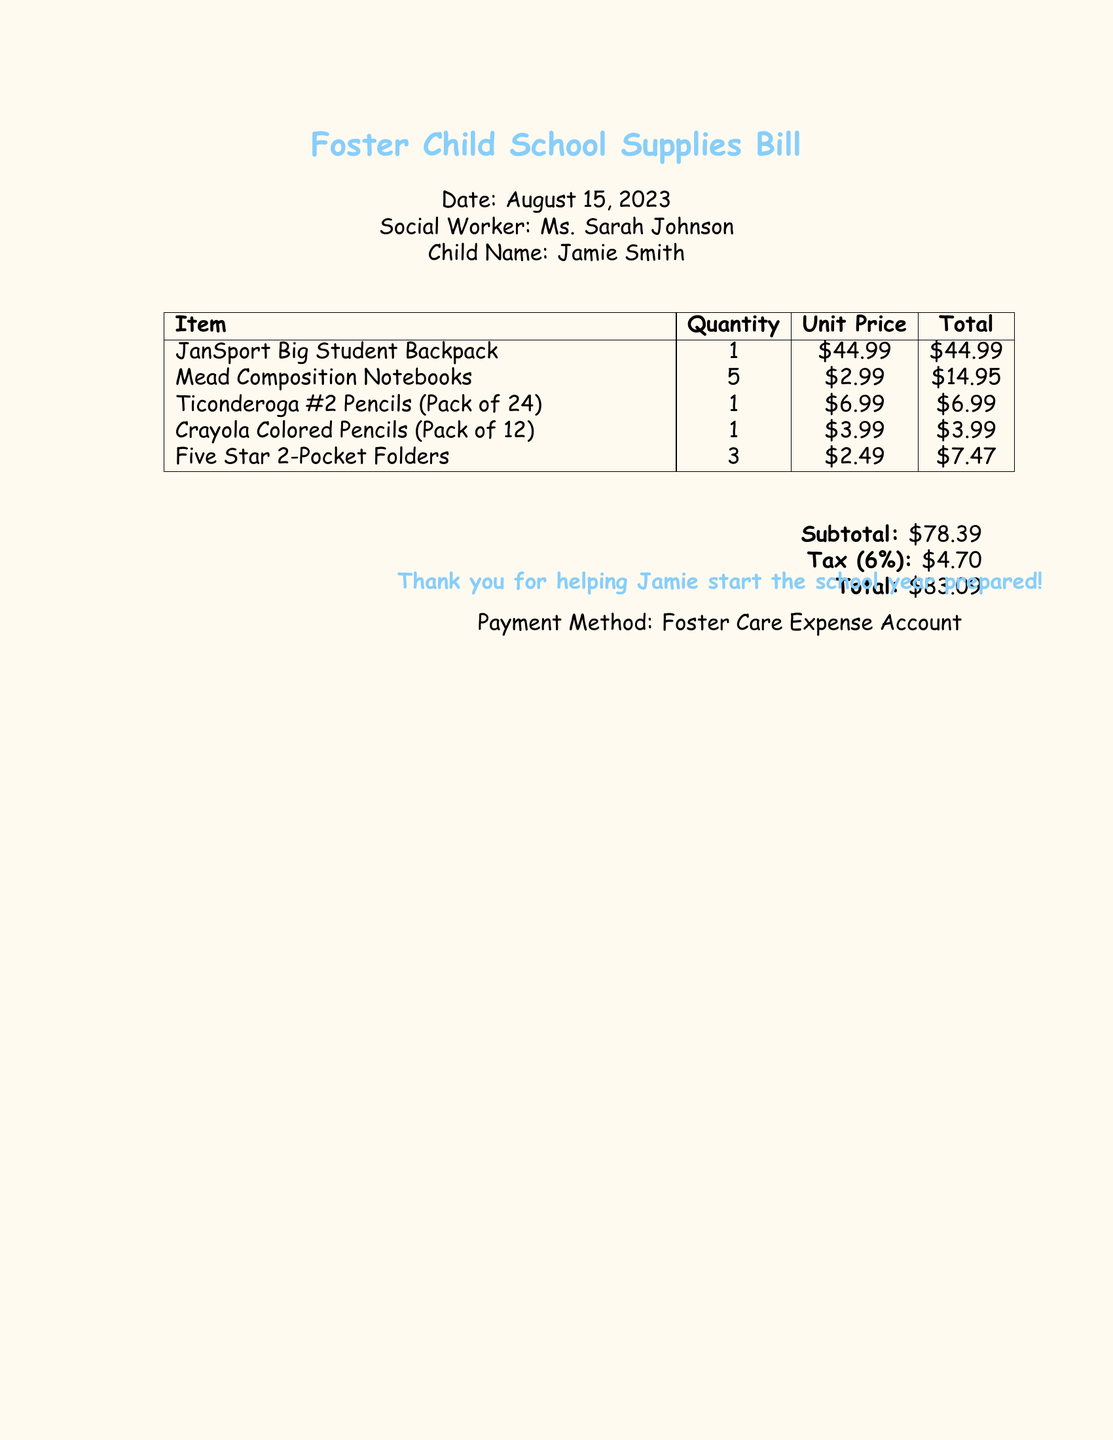What is the date of the bill? The date of the bill is mentioned at the top of the document as August 15, 2023.
Answer: August 15, 2023 Who is the social worker? The social worker's name is provided in the document as Ms. Sarah Johnson.
Answer: Ms. Sarah Johnson What is the total cost of the school supplies? The total cost is calculated at the bottom of the bill and is listed as $83.09.
Answer: $83.09 How many notebooks are included in the bill? The document specifies that there are 5 Mead Composition Notebooks listed in the table.
Answer: 5 What is the subtotal amount? The subtotal amount before tax is shown in the document as $78.39.
Answer: $78.39 What color is the document background? The background color of the document is described as childbg, which implies a light color for children.
Answer: Light color How many Ticonderoga pencils are included in the pack? The document states that there is 1 pack of Ticonderoga #2 Pencils, which contains 24 pencils.
Answer: 24 What is the unit price of the backpack? The unit price for the JanSport Big Student Backpack is clearly mentioned in the document as $44.99.
Answer: $44.99 What method is used for payment? The method for payment is indicated at the bottom of the document as Foster Care Expense Account.
Answer: Foster Care Expense Account 